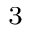<formula> <loc_0><loc_0><loc_500><loc_500>_ { 3 }</formula> 